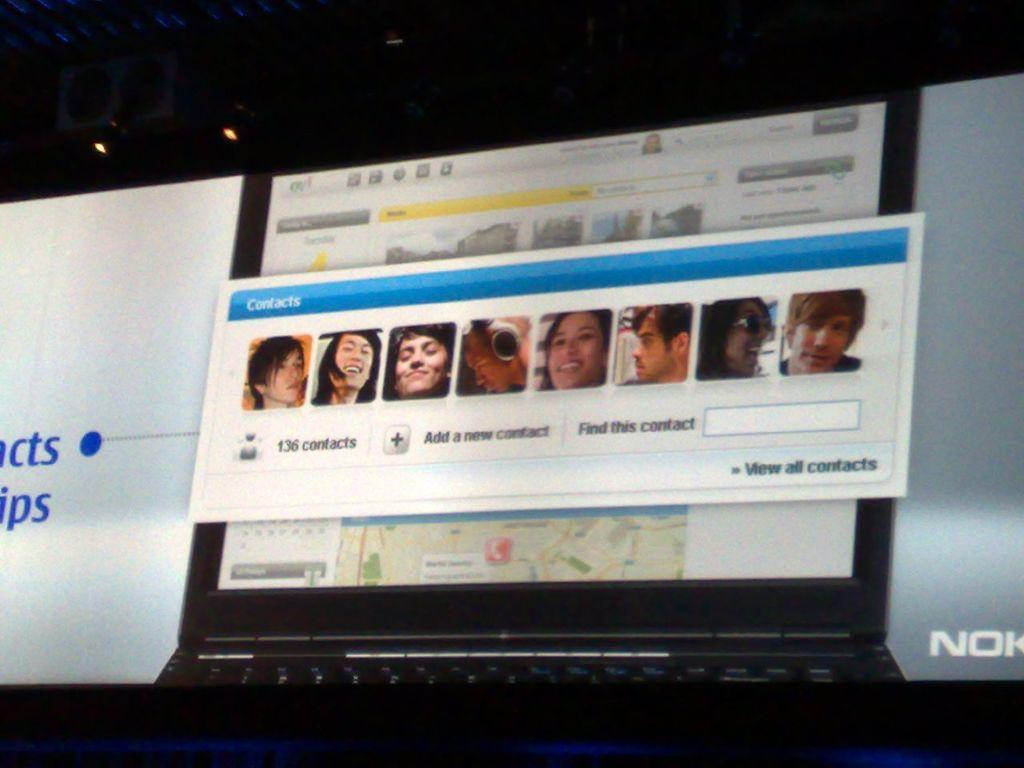Provide a one-sentence caption for the provided image. The view all contacts option can be seen below several pictures of people. 